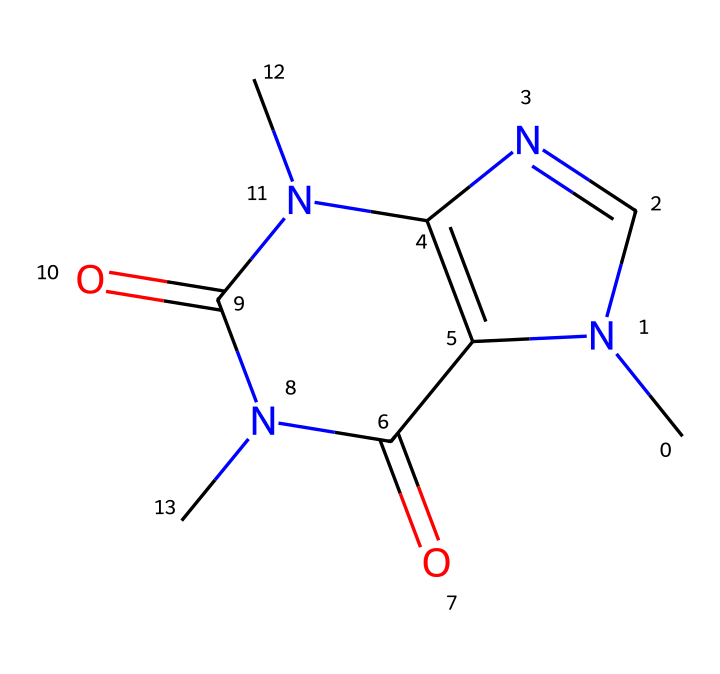What is the molecular formula of caffeine? To find the molecular formula, we count the number of each type of atom in the structure. The caffeine structure has 8 carbon atoms (C), 10 hydrogen atoms (H), 4 nitrogen atoms (N), and 2 oxygen atoms (O), resulting in the molecular formula C8H10N4O2.
Answer: C8H10N4O2 How many rings are present in the caffeine structure? By analyzing the SMILES representation, we can identify two distinct ring structures. The notation "N1" and "N2" indicates the presence of two fused rings in the structure of caffeine.
Answer: 2 What is the main type of nitrogen present in caffeine? Caffeine contains two types of nitrogen: amine and imine. However, there are no double bonds directly involving nitrogen in the caffeine structure, indicating that the primary nitrogen type is amine.
Answer: amine What is the hybridization of the carbon atoms in caffeine? The carbon atoms in caffeine are primarily sp2 hybridized due to their involvement in double bonds and being part of aromatic systems. This indicates that those carbon atoms are part of the planar structures in the rings.
Answer: sp2 What functional groups are found in caffeine? The caffeine structure includes two carbonyl groups (C=O) and amine groups (N). These groups are significant in determining the chemical reactivity and properties of caffeine.
Answer: carbonyl and amine How does caffeine's structure relate to its stimulant properties? Caffeine's structure contains nitrogen atoms in a heterocyclic aromatic compound, which are crucial for binding to adenosine receptors in the brain. This binding inhibits the action of adenosine, a neurotransmitter that causes drowsiness, leading to increased alertness.
Answer: heterocyclic aromatic compound What is the relationship between caffeine and its solubility in water? The presence of polar functional groups, particularly the carbonyl and amine groups, contributes to caffeine's solubility in water, allowing it to dissolve readily compared to non-polar compounds.
Answer: polar functional groups 